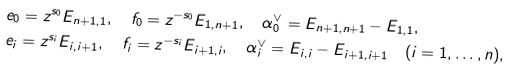Convert formula to latex. <formula><loc_0><loc_0><loc_500><loc_500>& e _ { 0 } = z ^ { s _ { 0 } } E _ { n + 1 , 1 } , \quad f _ { 0 } = z ^ { - s _ { 0 } } E _ { 1 , n + 1 } , \quad \alpha ^ { \vee } _ { 0 } = E _ { n + 1 , n + 1 } - E _ { 1 , 1 } , \\ & e _ { i } = z ^ { s _ { i } } E _ { i , i + 1 } , \quad f _ { i } = z ^ { - s _ { i } } E _ { i + 1 , i } , \quad \alpha ^ { \vee } _ { i } = E _ { i , i } - E _ { i + 1 , i + 1 } \quad ( i = 1 , \dots , n ) ,</formula> 